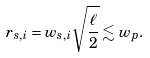Convert formula to latex. <formula><loc_0><loc_0><loc_500><loc_500>r _ { s , i } = w _ { s , i } \sqrt { \frac { \ell } { 2 } } \lesssim w _ { p } .</formula> 